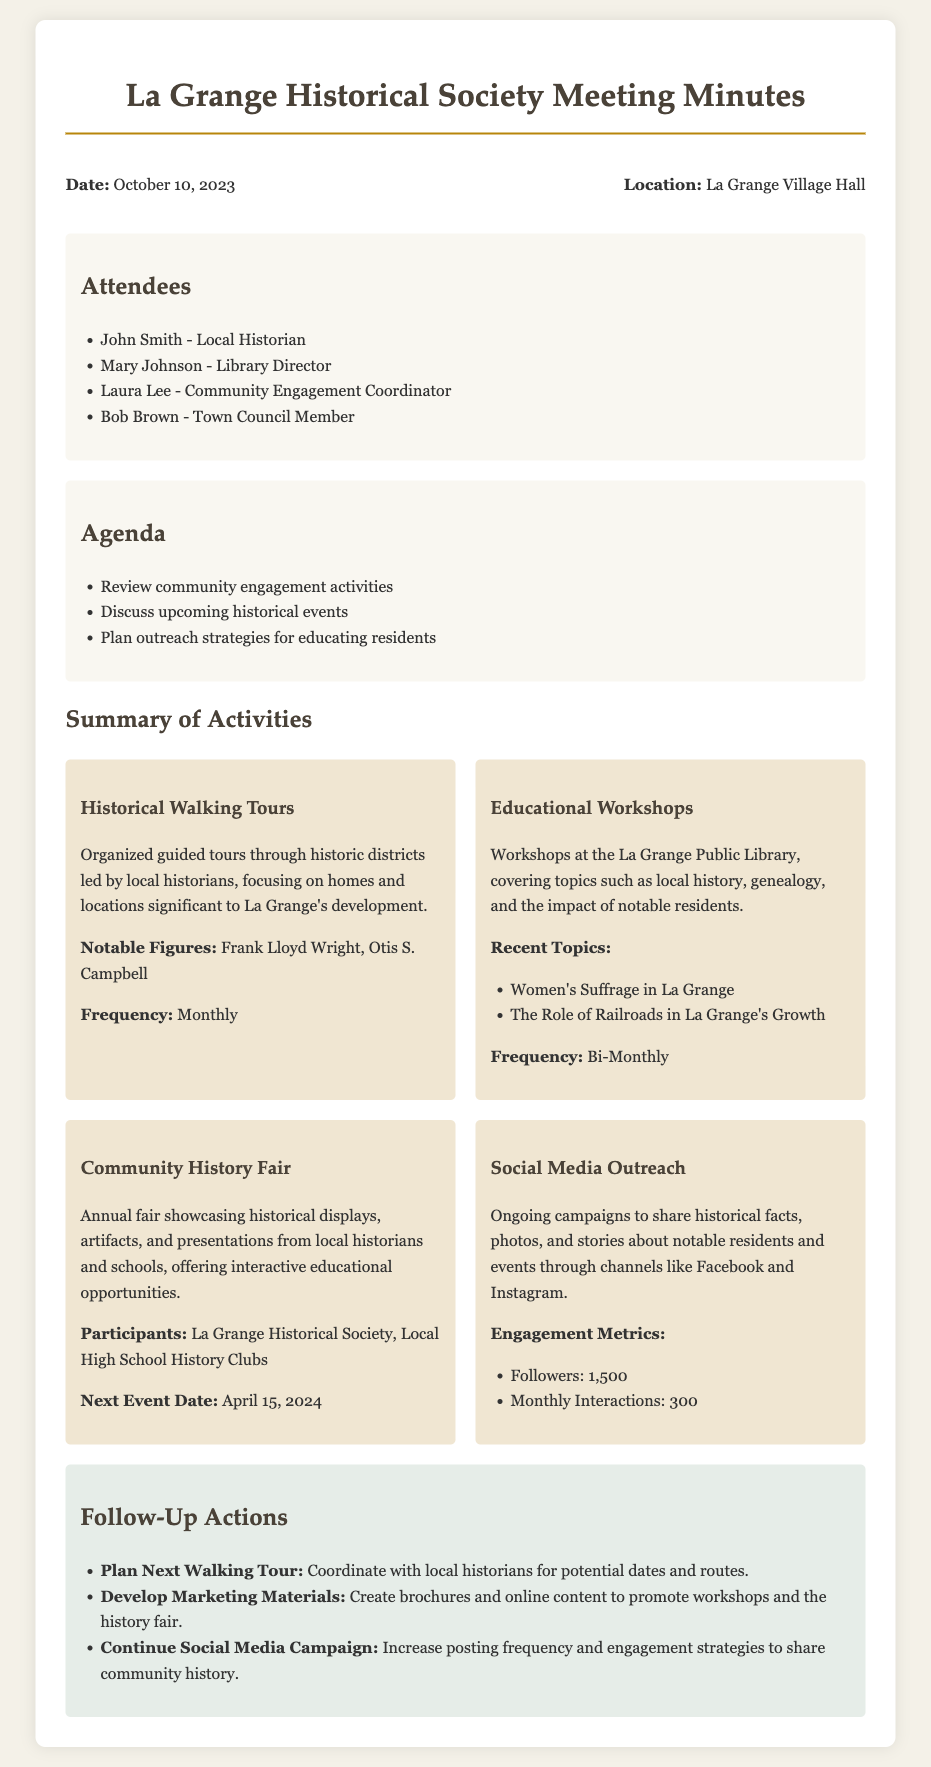what is the date of the meeting? The date of the meeting is explicitly mentioned in the document as October 10, 2023.
Answer: October 10, 2023 who organized the Historical Walking Tours? The document states that the Historical Walking Tours are organized by local historians.
Answer: Local historians what is the next event for the Community History Fair? The next event date for the Community History Fair is indicated in the document as April 15, 2024.
Answer: April 15, 2024 how frequently are Educational Workshops held? The document lists the frequency of Educational Workshops as Bi-Monthly.
Answer: Bi-Monthly what social media engagement metrics are provided? The document includes follower count and monthly interactions as social media engagement metrics.
Answer: 1,500 followers and 300 monthly interactions who is the Community Engagement Coordinator? The document identifies Laura Lee as the Community Engagement Coordinator in the attendees section.
Answer: Laura Lee what notable figures are highlighted in the Historical Walking Tours? The document specifies Frank Lloyd Wright and Otis S. Campbell as notable figures in the Historical Walking Tours.
Answer: Frank Lloyd Wright, Otis S. Campbell what are the follow-up actions listed in the document? The document details specific actions like planning the next walking tour, developing marketing materials, and continuing social media campaigns.
Answer: Plan next walking tour, develop marketing materials, continue social media campaign 